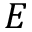<formula> <loc_0><loc_0><loc_500><loc_500>E</formula> 